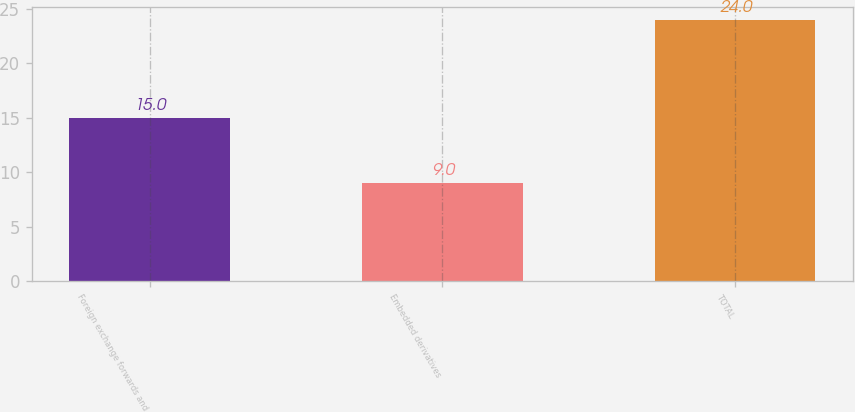Convert chart. <chart><loc_0><loc_0><loc_500><loc_500><bar_chart><fcel>Foreign exchange forwards and<fcel>Embedded derivatives<fcel>TOTAL<nl><fcel>15<fcel>9<fcel>24<nl></chart> 